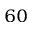<formula> <loc_0><loc_0><loc_500><loc_500>^ { 6 0 }</formula> 